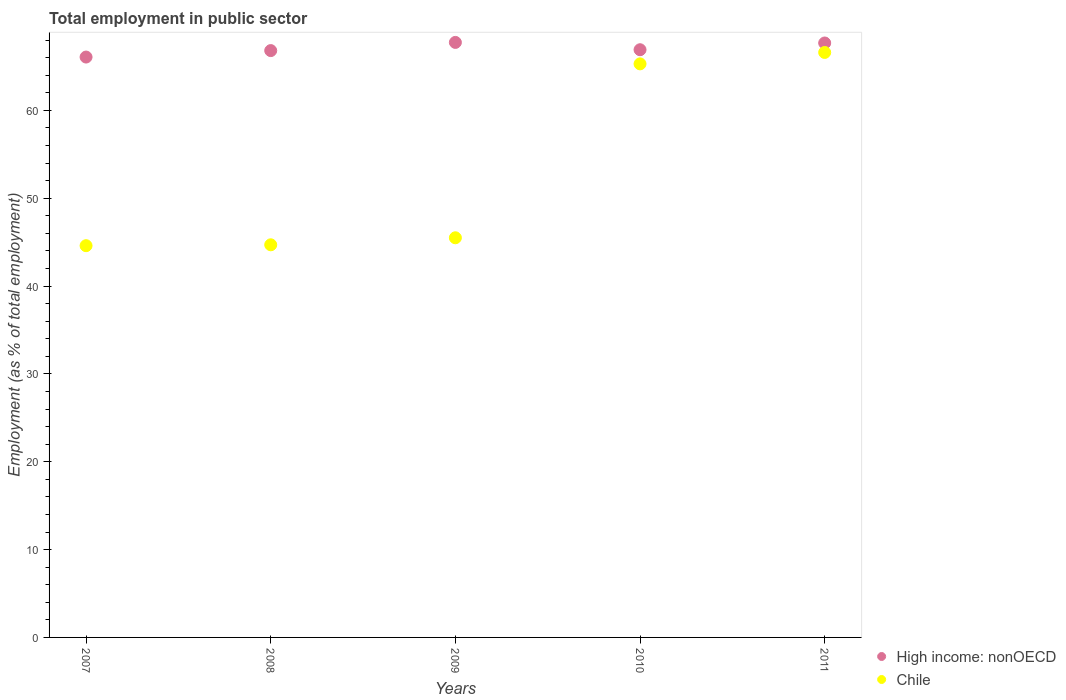Is the number of dotlines equal to the number of legend labels?
Provide a succinct answer. Yes. What is the employment in public sector in High income: nonOECD in 2011?
Offer a very short reply. 67.68. Across all years, what is the maximum employment in public sector in High income: nonOECD?
Your response must be concise. 67.74. Across all years, what is the minimum employment in public sector in Chile?
Provide a short and direct response. 44.6. What is the total employment in public sector in High income: nonOECD in the graph?
Provide a succinct answer. 335.21. What is the difference between the employment in public sector in High income: nonOECD in 2007 and that in 2011?
Keep it short and to the point. -1.6. What is the difference between the employment in public sector in High income: nonOECD in 2007 and the employment in public sector in Chile in 2008?
Your answer should be very brief. 21.37. What is the average employment in public sector in High income: nonOECD per year?
Provide a short and direct response. 67.04. In the year 2011, what is the difference between the employment in public sector in High income: nonOECD and employment in public sector in Chile?
Make the answer very short. 1.08. In how many years, is the employment in public sector in High income: nonOECD greater than 6 %?
Keep it short and to the point. 5. What is the ratio of the employment in public sector in High income: nonOECD in 2009 to that in 2011?
Provide a succinct answer. 1. What is the difference between the highest and the second highest employment in public sector in High income: nonOECD?
Make the answer very short. 0.07. What is the difference between the highest and the lowest employment in public sector in Chile?
Make the answer very short. 22. Is the sum of the employment in public sector in Chile in 2009 and 2011 greater than the maximum employment in public sector in High income: nonOECD across all years?
Provide a succinct answer. Yes. Does the employment in public sector in High income: nonOECD monotonically increase over the years?
Provide a succinct answer. No. Is the employment in public sector in Chile strictly greater than the employment in public sector in High income: nonOECD over the years?
Your response must be concise. No. Is the employment in public sector in Chile strictly less than the employment in public sector in High income: nonOECD over the years?
Your response must be concise. Yes. Does the graph contain any zero values?
Provide a succinct answer. No. Does the graph contain grids?
Offer a terse response. No. How many legend labels are there?
Provide a short and direct response. 2. What is the title of the graph?
Make the answer very short. Total employment in public sector. What is the label or title of the Y-axis?
Give a very brief answer. Employment (as % of total employment). What is the Employment (as % of total employment) in High income: nonOECD in 2007?
Ensure brevity in your answer.  66.07. What is the Employment (as % of total employment) in Chile in 2007?
Provide a succinct answer. 44.6. What is the Employment (as % of total employment) of High income: nonOECD in 2008?
Offer a terse response. 66.81. What is the Employment (as % of total employment) of Chile in 2008?
Provide a succinct answer. 44.7. What is the Employment (as % of total employment) in High income: nonOECD in 2009?
Your answer should be very brief. 67.74. What is the Employment (as % of total employment) of Chile in 2009?
Provide a succinct answer. 45.5. What is the Employment (as % of total employment) in High income: nonOECD in 2010?
Your answer should be compact. 66.91. What is the Employment (as % of total employment) in Chile in 2010?
Your answer should be very brief. 65.3. What is the Employment (as % of total employment) of High income: nonOECD in 2011?
Ensure brevity in your answer.  67.68. What is the Employment (as % of total employment) of Chile in 2011?
Provide a short and direct response. 66.6. Across all years, what is the maximum Employment (as % of total employment) in High income: nonOECD?
Offer a terse response. 67.74. Across all years, what is the maximum Employment (as % of total employment) in Chile?
Ensure brevity in your answer.  66.6. Across all years, what is the minimum Employment (as % of total employment) in High income: nonOECD?
Ensure brevity in your answer.  66.07. Across all years, what is the minimum Employment (as % of total employment) in Chile?
Give a very brief answer. 44.6. What is the total Employment (as % of total employment) of High income: nonOECD in the graph?
Make the answer very short. 335.21. What is the total Employment (as % of total employment) in Chile in the graph?
Offer a very short reply. 266.7. What is the difference between the Employment (as % of total employment) of High income: nonOECD in 2007 and that in 2008?
Your answer should be compact. -0.74. What is the difference between the Employment (as % of total employment) in Chile in 2007 and that in 2008?
Give a very brief answer. -0.1. What is the difference between the Employment (as % of total employment) of High income: nonOECD in 2007 and that in 2009?
Your response must be concise. -1.67. What is the difference between the Employment (as % of total employment) of Chile in 2007 and that in 2009?
Keep it short and to the point. -0.9. What is the difference between the Employment (as % of total employment) of High income: nonOECD in 2007 and that in 2010?
Offer a terse response. -0.83. What is the difference between the Employment (as % of total employment) in Chile in 2007 and that in 2010?
Make the answer very short. -20.7. What is the difference between the Employment (as % of total employment) of High income: nonOECD in 2007 and that in 2011?
Give a very brief answer. -1.6. What is the difference between the Employment (as % of total employment) of High income: nonOECD in 2008 and that in 2009?
Your answer should be very brief. -0.93. What is the difference between the Employment (as % of total employment) of High income: nonOECD in 2008 and that in 2010?
Provide a short and direct response. -0.1. What is the difference between the Employment (as % of total employment) of Chile in 2008 and that in 2010?
Your response must be concise. -20.6. What is the difference between the Employment (as % of total employment) in High income: nonOECD in 2008 and that in 2011?
Your response must be concise. -0.87. What is the difference between the Employment (as % of total employment) of Chile in 2008 and that in 2011?
Ensure brevity in your answer.  -21.9. What is the difference between the Employment (as % of total employment) in High income: nonOECD in 2009 and that in 2010?
Give a very brief answer. 0.83. What is the difference between the Employment (as % of total employment) of Chile in 2009 and that in 2010?
Offer a very short reply. -19.8. What is the difference between the Employment (as % of total employment) of High income: nonOECD in 2009 and that in 2011?
Give a very brief answer. 0.07. What is the difference between the Employment (as % of total employment) in Chile in 2009 and that in 2011?
Your answer should be very brief. -21.1. What is the difference between the Employment (as % of total employment) in High income: nonOECD in 2010 and that in 2011?
Keep it short and to the point. -0.77. What is the difference between the Employment (as % of total employment) in Chile in 2010 and that in 2011?
Keep it short and to the point. -1.3. What is the difference between the Employment (as % of total employment) in High income: nonOECD in 2007 and the Employment (as % of total employment) in Chile in 2008?
Keep it short and to the point. 21.38. What is the difference between the Employment (as % of total employment) of High income: nonOECD in 2007 and the Employment (as % of total employment) of Chile in 2009?
Keep it short and to the point. 20.57. What is the difference between the Employment (as % of total employment) in High income: nonOECD in 2007 and the Employment (as % of total employment) in Chile in 2010?
Provide a short and direct response. 0.78. What is the difference between the Employment (as % of total employment) in High income: nonOECD in 2007 and the Employment (as % of total employment) in Chile in 2011?
Give a very brief answer. -0.53. What is the difference between the Employment (as % of total employment) in High income: nonOECD in 2008 and the Employment (as % of total employment) in Chile in 2009?
Provide a succinct answer. 21.31. What is the difference between the Employment (as % of total employment) of High income: nonOECD in 2008 and the Employment (as % of total employment) of Chile in 2010?
Your answer should be compact. 1.51. What is the difference between the Employment (as % of total employment) in High income: nonOECD in 2008 and the Employment (as % of total employment) in Chile in 2011?
Keep it short and to the point. 0.21. What is the difference between the Employment (as % of total employment) in High income: nonOECD in 2009 and the Employment (as % of total employment) in Chile in 2010?
Ensure brevity in your answer.  2.44. What is the difference between the Employment (as % of total employment) in High income: nonOECD in 2009 and the Employment (as % of total employment) in Chile in 2011?
Your answer should be very brief. 1.14. What is the difference between the Employment (as % of total employment) of High income: nonOECD in 2010 and the Employment (as % of total employment) of Chile in 2011?
Your answer should be very brief. 0.31. What is the average Employment (as % of total employment) in High income: nonOECD per year?
Provide a short and direct response. 67.04. What is the average Employment (as % of total employment) of Chile per year?
Give a very brief answer. 53.34. In the year 2007, what is the difference between the Employment (as % of total employment) of High income: nonOECD and Employment (as % of total employment) of Chile?
Your answer should be very brief. 21.48. In the year 2008, what is the difference between the Employment (as % of total employment) in High income: nonOECD and Employment (as % of total employment) in Chile?
Your response must be concise. 22.11. In the year 2009, what is the difference between the Employment (as % of total employment) in High income: nonOECD and Employment (as % of total employment) in Chile?
Your answer should be compact. 22.24. In the year 2010, what is the difference between the Employment (as % of total employment) of High income: nonOECD and Employment (as % of total employment) of Chile?
Ensure brevity in your answer.  1.61. In the year 2011, what is the difference between the Employment (as % of total employment) of High income: nonOECD and Employment (as % of total employment) of Chile?
Your answer should be compact. 1.08. What is the ratio of the Employment (as % of total employment) of High income: nonOECD in 2007 to that in 2008?
Give a very brief answer. 0.99. What is the ratio of the Employment (as % of total employment) of Chile in 2007 to that in 2008?
Offer a terse response. 1. What is the ratio of the Employment (as % of total employment) of High income: nonOECD in 2007 to that in 2009?
Your answer should be compact. 0.98. What is the ratio of the Employment (as % of total employment) of Chile in 2007 to that in 2009?
Provide a succinct answer. 0.98. What is the ratio of the Employment (as % of total employment) of High income: nonOECD in 2007 to that in 2010?
Provide a short and direct response. 0.99. What is the ratio of the Employment (as % of total employment) of Chile in 2007 to that in 2010?
Offer a very short reply. 0.68. What is the ratio of the Employment (as % of total employment) in High income: nonOECD in 2007 to that in 2011?
Your response must be concise. 0.98. What is the ratio of the Employment (as % of total employment) in Chile in 2007 to that in 2011?
Offer a terse response. 0.67. What is the ratio of the Employment (as % of total employment) of High income: nonOECD in 2008 to that in 2009?
Provide a succinct answer. 0.99. What is the ratio of the Employment (as % of total employment) of Chile in 2008 to that in 2009?
Ensure brevity in your answer.  0.98. What is the ratio of the Employment (as % of total employment) of Chile in 2008 to that in 2010?
Offer a very short reply. 0.68. What is the ratio of the Employment (as % of total employment) of High income: nonOECD in 2008 to that in 2011?
Give a very brief answer. 0.99. What is the ratio of the Employment (as % of total employment) in Chile in 2008 to that in 2011?
Ensure brevity in your answer.  0.67. What is the ratio of the Employment (as % of total employment) in High income: nonOECD in 2009 to that in 2010?
Your answer should be very brief. 1.01. What is the ratio of the Employment (as % of total employment) in Chile in 2009 to that in 2010?
Ensure brevity in your answer.  0.7. What is the ratio of the Employment (as % of total employment) in High income: nonOECD in 2009 to that in 2011?
Your answer should be compact. 1. What is the ratio of the Employment (as % of total employment) in Chile in 2009 to that in 2011?
Your answer should be compact. 0.68. What is the ratio of the Employment (as % of total employment) of High income: nonOECD in 2010 to that in 2011?
Ensure brevity in your answer.  0.99. What is the ratio of the Employment (as % of total employment) in Chile in 2010 to that in 2011?
Give a very brief answer. 0.98. What is the difference between the highest and the second highest Employment (as % of total employment) in High income: nonOECD?
Your answer should be compact. 0.07. What is the difference between the highest and the second highest Employment (as % of total employment) in Chile?
Offer a terse response. 1.3. What is the difference between the highest and the lowest Employment (as % of total employment) in High income: nonOECD?
Ensure brevity in your answer.  1.67. What is the difference between the highest and the lowest Employment (as % of total employment) in Chile?
Your response must be concise. 22. 